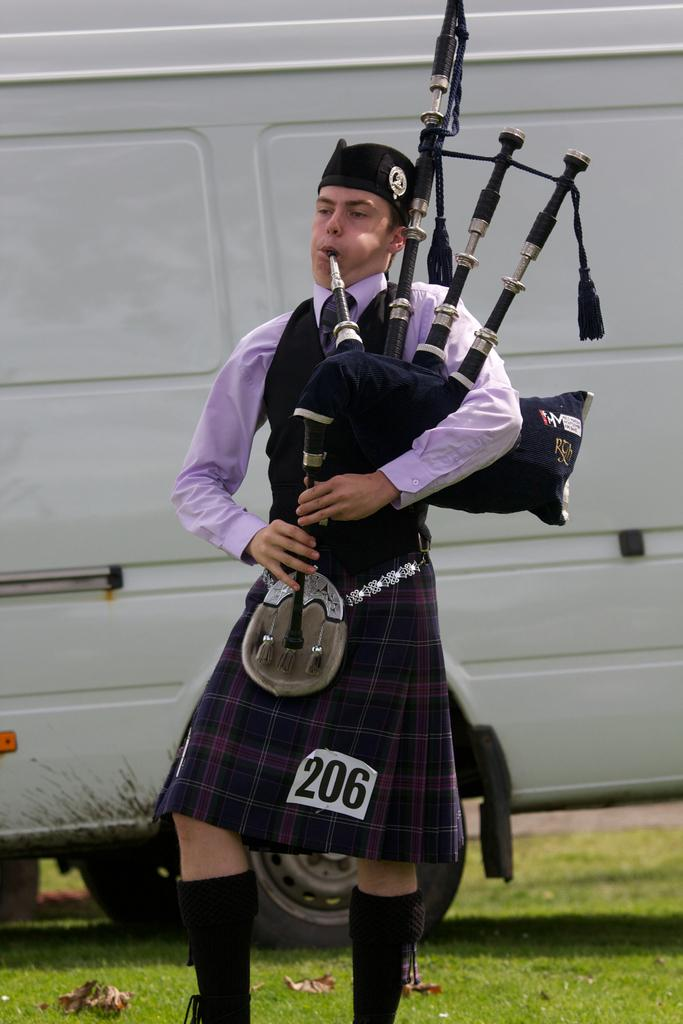What is the main subject of the image? There is a person standing in the center of the image. What is the person holding in the image? The person is holding a bag piper. What can be seen in the background of the image? There is a vehicle visible in the background, and grass is present as well. What type of collar can be seen on the person in the image? There is no collar visible on the person in the image. How many parts of the vehicle can be seen in the image? The image only shows a portion of the vehicle, so it is not possible to determine the number of parts visible. 